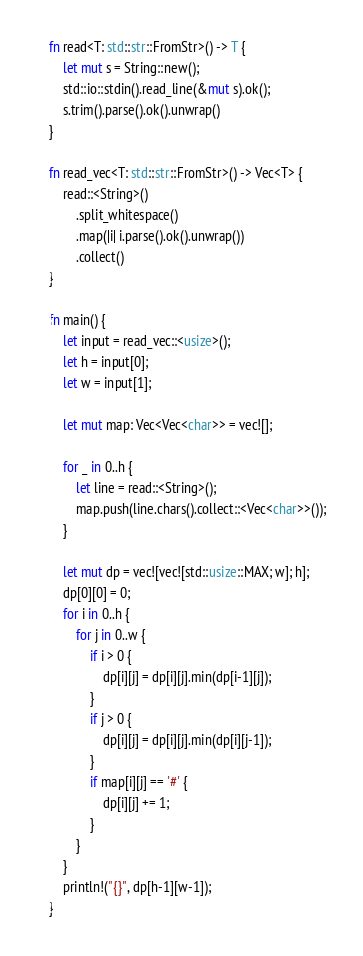Convert code to text. <code><loc_0><loc_0><loc_500><loc_500><_Rust_>fn read<T: std::str::FromStr>() -> T {
    let mut s = String::new();
    std::io::stdin().read_line(&mut s).ok();
    s.trim().parse().ok().unwrap()
}

fn read_vec<T: std::str::FromStr>() -> Vec<T> {
    read::<String>()
        .split_whitespace()
        .map(|i| i.parse().ok().unwrap())
        .collect()
}

fn main() {
    let input = read_vec::<usize>();
    let h = input[0];
    let w = input[1];

    let mut map: Vec<Vec<char>> = vec![];

    for _ in 0..h {
        let line = read::<String>();
        map.push(line.chars().collect::<Vec<char>>());
    }

    let mut dp = vec![vec![std::usize::MAX; w]; h];
    dp[0][0] = 0;
    for i in 0..h {
        for j in 0..w {
            if i > 0 {
                dp[i][j] = dp[i][j].min(dp[i-1][j]);
            }
            if j > 0 {
                dp[i][j] = dp[i][j].min(dp[i][j-1]);
            }
            if map[i][j] == '#' {
                dp[i][j] += 1;
            }
        }
    }
    println!("{}", dp[h-1][w-1]);
}
</code> 